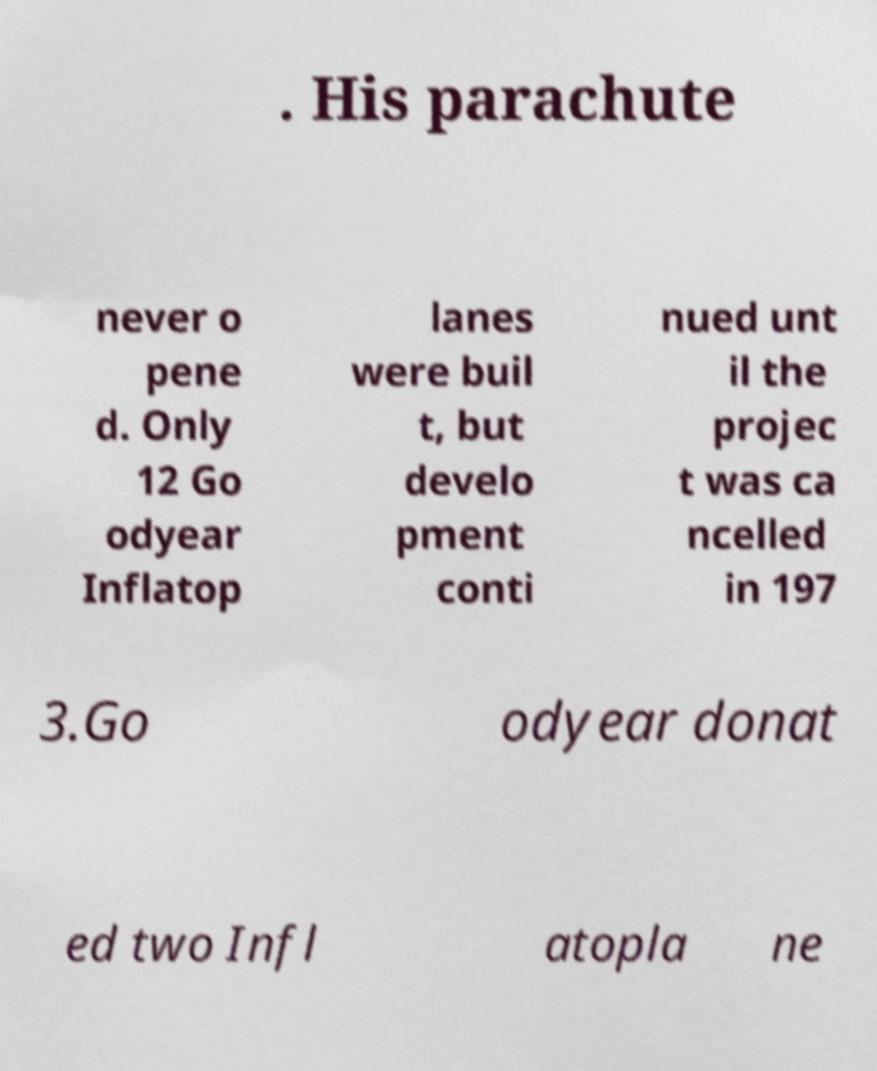What messages or text are displayed in this image? I need them in a readable, typed format. . His parachute never o pene d. Only 12 Go odyear Inflatop lanes were buil t, but develo pment conti nued unt il the projec t was ca ncelled in 197 3.Go odyear donat ed two Infl atopla ne 